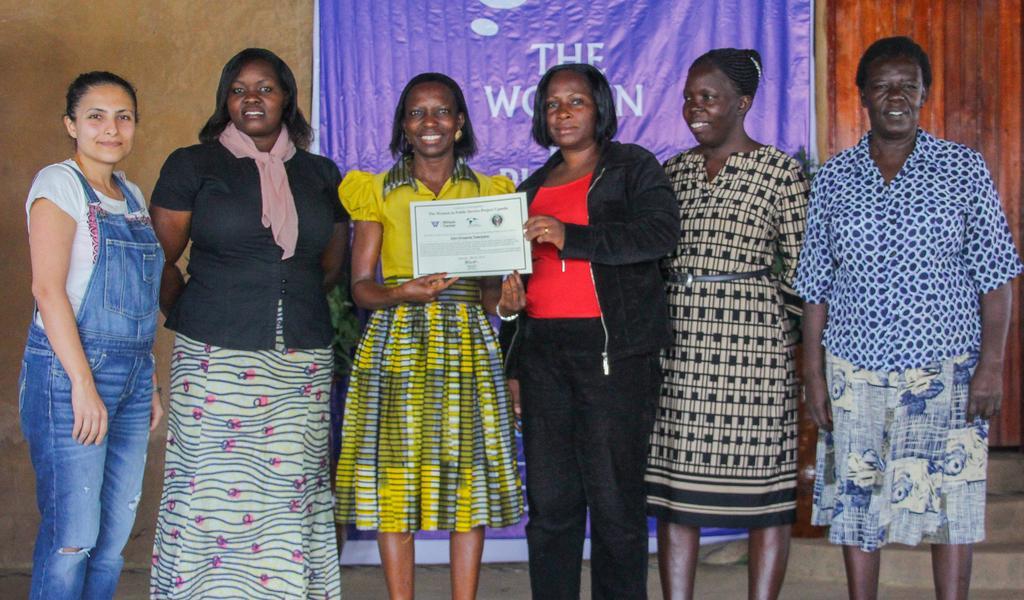How would you summarize this image in a sentence or two? In this picture we can see a group of people standing. We can see two women holding an object. There are stairs and some text visible on the banner in the background. 